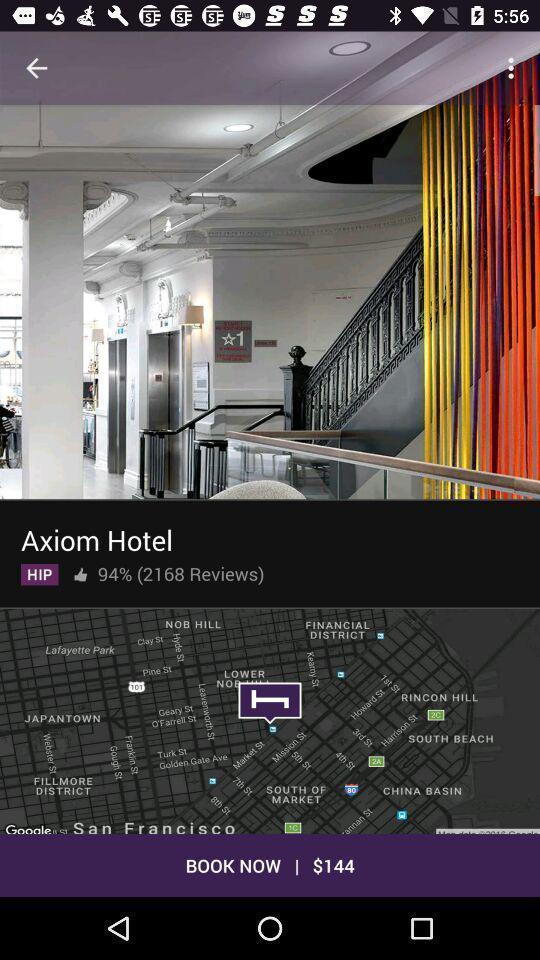Describe the visual elements of this screenshot. Screen displaying the hotel and its price for booking. 